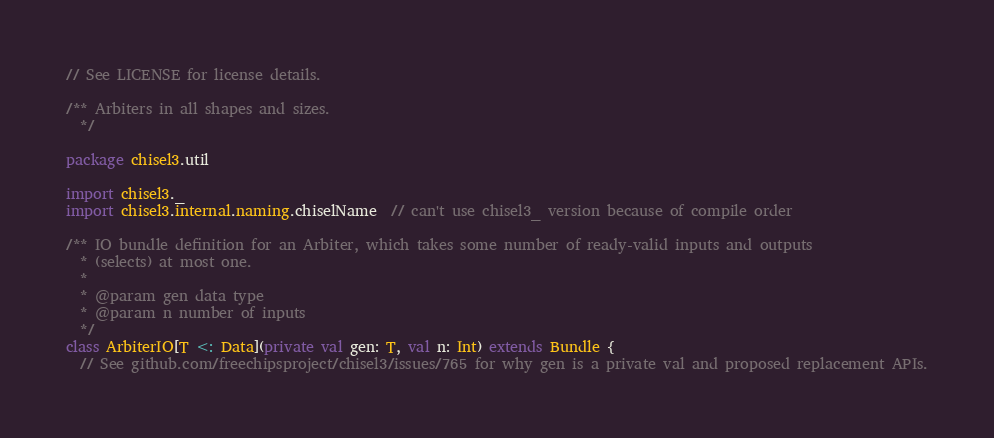<code> <loc_0><loc_0><loc_500><loc_500><_Scala_>// See LICENSE for license details.

/** Arbiters in all shapes and sizes.
  */

package chisel3.util

import chisel3._
import chisel3.internal.naming.chiselName  // can't use chisel3_ version because of compile order

/** IO bundle definition for an Arbiter, which takes some number of ready-valid inputs and outputs
  * (selects) at most one.
  *
  * @param gen data type
  * @param n number of inputs
  */
class ArbiterIO[T <: Data](private val gen: T, val n: Int) extends Bundle {
  // See github.com/freechipsproject/chisel3/issues/765 for why gen is a private val and proposed replacement APIs.
</code> 